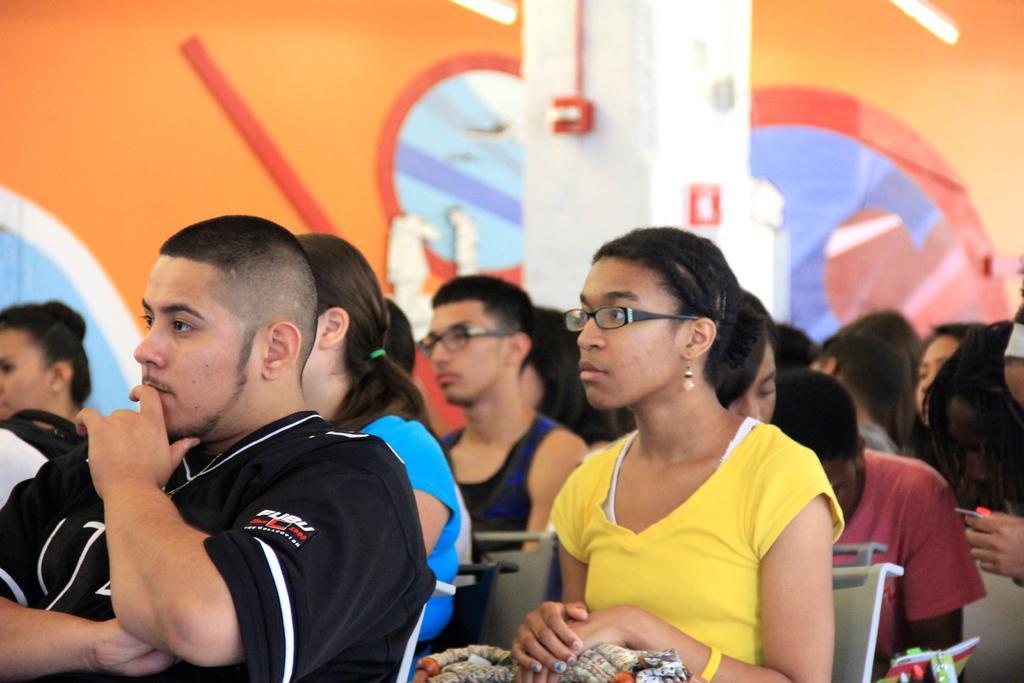In one or two sentences, can you explain what this image depicts? In this picture we can see so many people are sitting on the chairs. 